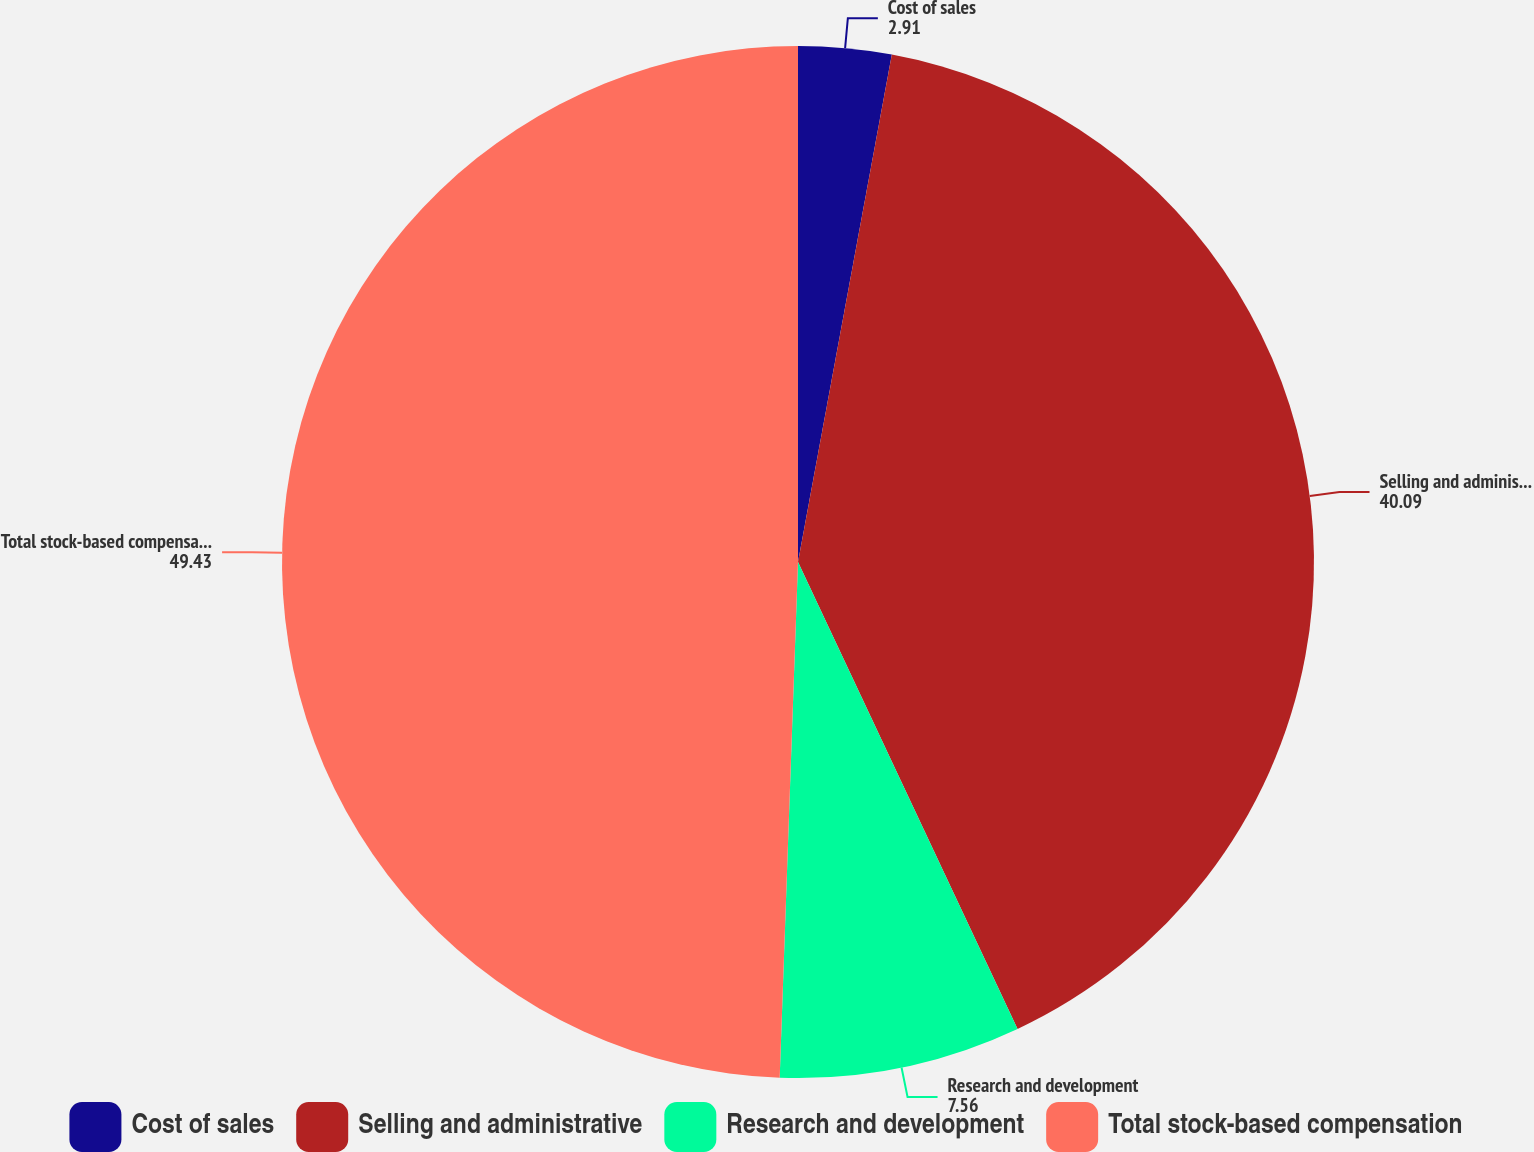<chart> <loc_0><loc_0><loc_500><loc_500><pie_chart><fcel>Cost of sales<fcel>Selling and administrative<fcel>Research and development<fcel>Total stock-based compensation<nl><fcel>2.91%<fcel>40.09%<fcel>7.56%<fcel>49.43%<nl></chart> 